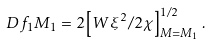Convert formula to latex. <formula><loc_0><loc_0><loc_500><loc_500>\ D { f _ { 1 } } { M _ { 1 } } = 2 \left [ W \xi ^ { 2 } / 2 \chi \right ] ^ { 1 / 2 } _ { M = M _ { 1 } } .</formula> 